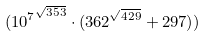<formula> <loc_0><loc_0><loc_500><loc_500>( { 1 0 ^ { 7 } } ^ { \sqrt { 3 5 3 } } \cdot ( 3 6 2 ^ { \sqrt { 4 2 9 } } + 2 9 7 ) )</formula> 